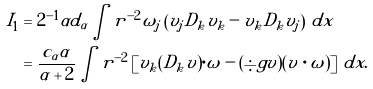Convert formula to latex. <formula><loc_0><loc_0><loc_500><loc_500>I _ { 1 } & = 2 ^ { - 1 } \alpha d _ { \alpha } \int r ^ { - 2 } \omega _ { j } \left ( v _ { j } D _ { k } v _ { k } - v _ { k } D _ { k } v _ { j } \right ) \, d x \\ & = \frac { c _ { \alpha } \alpha } { \alpha + 2 } \int r ^ { - 2 } \left [ v _ { k } ( D _ { k } v ) \cdot \omega - ( \div g v ) ( v \cdot \omega ) \right ] \, d x .</formula> 